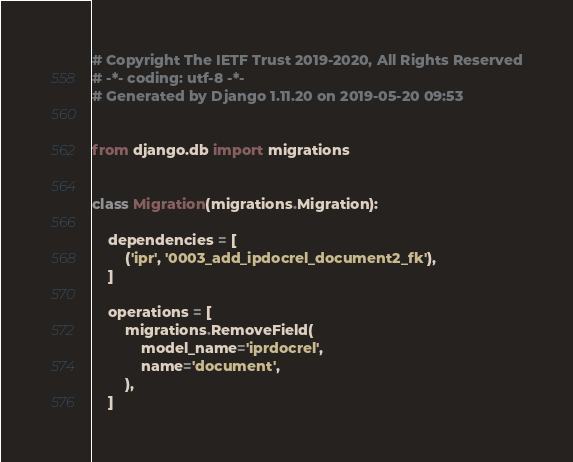Convert code to text. <code><loc_0><loc_0><loc_500><loc_500><_Python_># Copyright The IETF Trust 2019-2020, All Rights Reserved
# -*- coding: utf-8 -*-
# Generated by Django 1.11.20 on 2019-05-20 09:53


from django.db import migrations


class Migration(migrations.Migration):

    dependencies = [
        ('ipr', '0003_add_ipdocrel_document2_fk'),
    ]

    operations = [
        migrations.RemoveField(
            model_name='iprdocrel',
            name='document',
        ),
    ]
</code> 